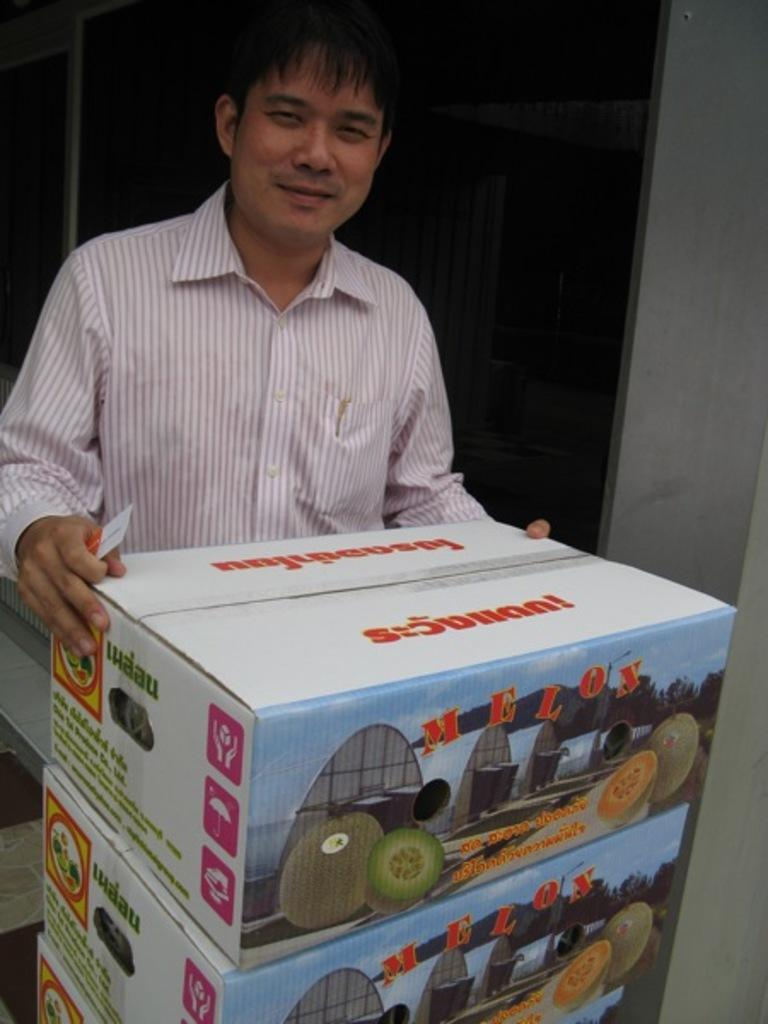<image>
Describe the image concisely. A man is holding a box with the word Melon on it. 